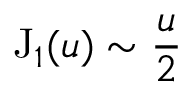Convert formula to latex. <formula><loc_0><loc_0><loc_500><loc_500>J _ { 1 } ( u ) \sim \frac { u } { 2 }</formula> 